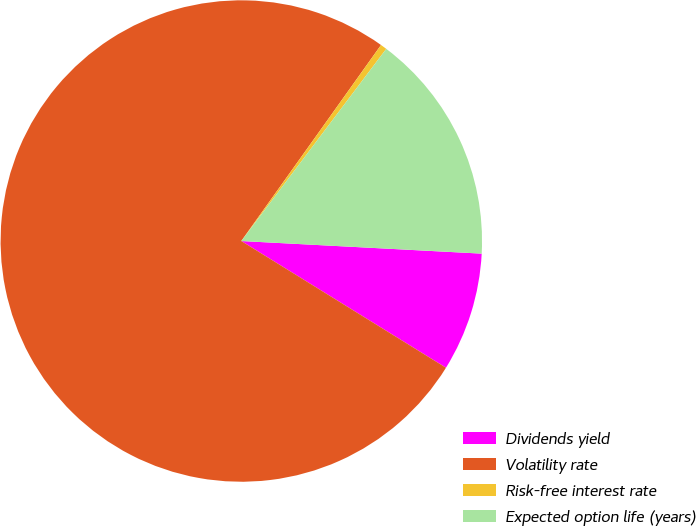<chart> <loc_0><loc_0><loc_500><loc_500><pie_chart><fcel>Dividends yield<fcel>Volatility rate<fcel>Risk-free interest rate<fcel>Expected option life (years)<nl><fcel>7.99%<fcel>76.04%<fcel>0.43%<fcel>15.55%<nl></chart> 